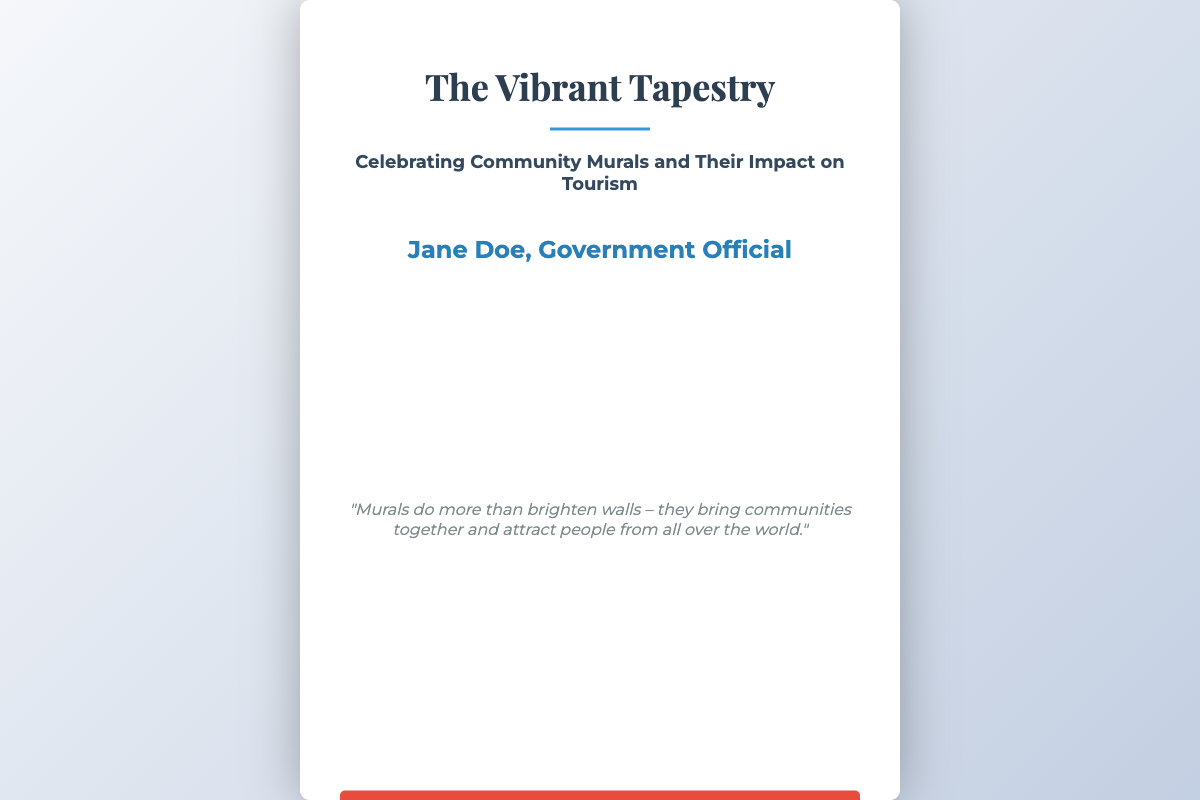What is the title of the book? The title is prominently displayed at the top of the cover.
Answer: The Vibrant Tapestry Who is the author of the book? The author's name is mentioned at the bottom of the cover.
Answer: Jane Doe What is the subtitle of the book? The subtitle provides additional context about the book's focus.
Answer: Celebrating Community Murals and Their Impact on Tourism What color is the Call To Action button? The CTA button color is visually striking and noticeable on the cover.
Answer: Red What style is the quote written in? The quote has a distinct visual style compared to other text elements.
Answer: Italic What does the quote mention about murals? The quote highlights the role of murals in the community and tourism.
Answer: They bring communities together and attract people from all over the world How many decorative lines are there on the cover? There is one decorative line that enhances the cover design.
Answer: One What is the background style of the book cover? The background is an image that reinforces the book's theme.
Answer: Mural What font style is used for the title? The font choice for the title is important for emphasis and design.
Answer: Playfair Display 